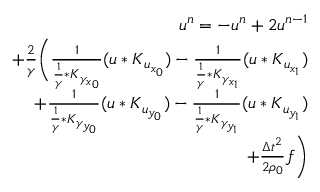<formula> <loc_0><loc_0><loc_500><loc_500>\begin{array} { r } { u ^ { n } = - u ^ { n } + 2 u ^ { n - 1 } } \\ { + \frac { 2 } { \gamma } \left ( \frac { 1 } { \frac { 1 } { \gamma } * K _ { \gamma _ { x _ { 0 } } } } ( u * K _ { u _ { x _ { 0 } } } ) - \frac { 1 } { \frac { 1 } { \gamma } * K _ { \gamma _ { x _ { 1 } } } } ( u * K _ { u _ { x _ { 1 } } } ) } \\ { + \frac { 1 } { \frac { 1 } { \gamma } * K _ { \gamma _ { y _ { 0 } } } } ( u * K _ { u _ { y _ { 0 } } } ) - \frac { 1 } { \frac { 1 } { \gamma } * K _ { \gamma _ { y _ { 1 } } } } ( u * K _ { u _ { y _ { 1 } } } ) } \\ { + \frac { \Delta t ^ { 2 } } { 2 \rho _ { 0 } } f \right ) } \end{array}</formula> 